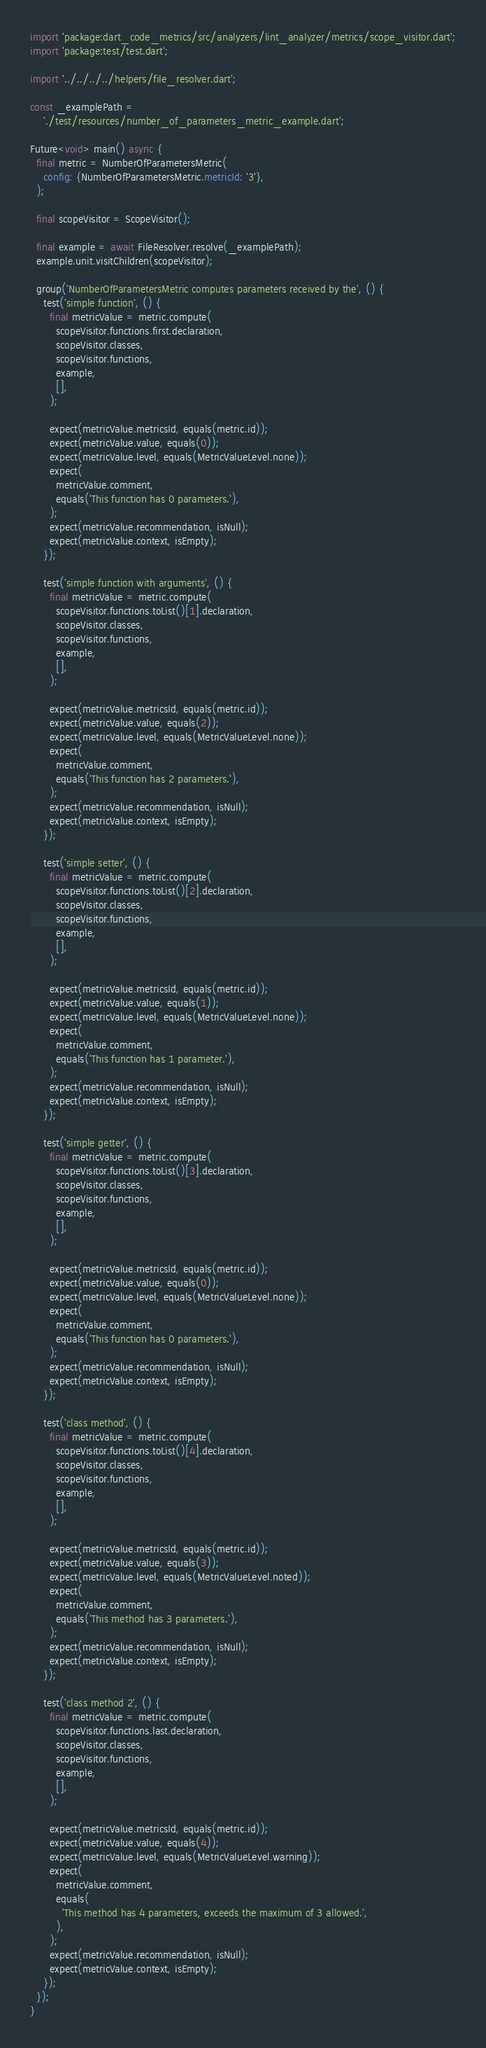Convert code to text. <code><loc_0><loc_0><loc_500><loc_500><_Dart_>import 'package:dart_code_metrics/src/analyzers/lint_analyzer/metrics/scope_visitor.dart';
import 'package:test/test.dart';

import '../../../../helpers/file_resolver.dart';

const _examplePath =
    './test/resources/number_of_parameters_metric_example.dart';

Future<void> main() async {
  final metric = NumberOfParametersMetric(
    config: {NumberOfParametersMetric.metricId: '3'},
  );

  final scopeVisitor = ScopeVisitor();

  final example = await FileResolver.resolve(_examplePath);
  example.unit.visitChildren(scopeVisitor);

  group('NumberOfParametersMetric computes parameters received by the', () {
    test('simple function', () {
      final metricValue = metric.compute(
        scopeVisitor.functions.first.declaration,
        scopeVisitor.classes,
        scopeVisitor.functions,
        example,
        [],
      );

      expect(metricValue.metricsId, equals(metric.id));
      expect(metricValue.value, equals(0));
      expect(metricValue.level, equals(MetricValueLevel.none));
      expect(
        metricValue.comment,
        equals('This function has 0 parameters.'),
      );
      expect(metricValue.recommendation, isNull);
      expect(metricValue.context, isEmpty);
    });

    test('simple function with arguments', () {
      final metricValue = metric.compute(
        scopeVisitor.functions.toList()[1].declaration,
        scopeVisitor.classes,
        scopeVisitor.functions,
        example,
        [],
      );

      expect(metricValue.metricsId, equals(metric.id));
      expect(metricValue.value, equals(2));
      expect(metricValue.level, equals(MetricValueLevel.none));
      expect(
        metricValue.comment,
        equals('This function has 2 parameters.'),
      );
      expect(metricValue.recommendation, isNull);
      expect(metricValue.context, isEmpty);
    });

    test('simple setter', () {
      final metricValue = metric.compute(
        scopeVisitor.functions.toList()[2].declaration,
        scopeVisitor.classes,
        scopeVisitor.functions,
        example,
        [],
      );

      expect(metricValue.metricsId, equals(metric.id));
      expect(metricValue.value, equals(1));
      expect(metricValue.level, equals(MetricValueLevel.none));
      expect(
        metricValue.comment,
        equals('This function has 1 parameter.'),
      );
      expect(metricValue.recommendation, isNull);
      expect(metricValue.context, isEmpty);
    });

    test('simple getter', () {
      final metricValue = metric.compute(
        scopeVisitor.functions.toList()[3].declaration,
        scopeVisitor.classes,
        scopeVisitor.functions,
        example,
        [],
      );

      expect(metricValue.metricsId, equals(metric.id));
      expect(metricValue.value, equals(0));
      expect(metricValue.level, equals(MetricValueLevel.none));
      expect(
        metricValue.comment,
        equals('This function has 0 parameters.'),
      );
      expect(metricValue.recommendation, isNull);
      expect(metricValue.context, isEmpty);
    });

    test('class method', () {
      final metricValue = metric.compute(
        scopeVisitor.functions.toList()[4].declaration,
        scopeVisitor.classes,
        scopeVisitor.functions,
        example,
        [],
      );

      expect(metricValue.metricsId, equals(metric.id));
      expect(metricValue.value, equals(3));
      expect(metricValue.level, equals(MetricValueLevel.noted));
      expect(
        metricValue.comment,
        equals('This method has 3 parameters.'),
      );
      expect(metricValue.recommendation, isNull);
      expect(metricValue.context, isEmpty);
    });

    test('class method 2', () {
      final metricValue = metric.compute(
        scopeVisitor.functions.last.declaration,
        scopeVisitor.classes,
        scopeVisitor.functions,
        example,
        [],
      );

      expect(metricValue.metricsId, equals(metric.id));
      expect(metricValue.value, equals(4));
      expect(metricValue.level, equals(MetricValueLevel.warning));
      expect(
        metricValue.comment,
        equals(
          'This method has 4 parameters, exceeds the maximum of 3 allowed.',
        ),
      );
      expect(metricValue.recommendation, isNull);
      expect(metricValue.context, isEmpty);
    });
  });
}
</code> 